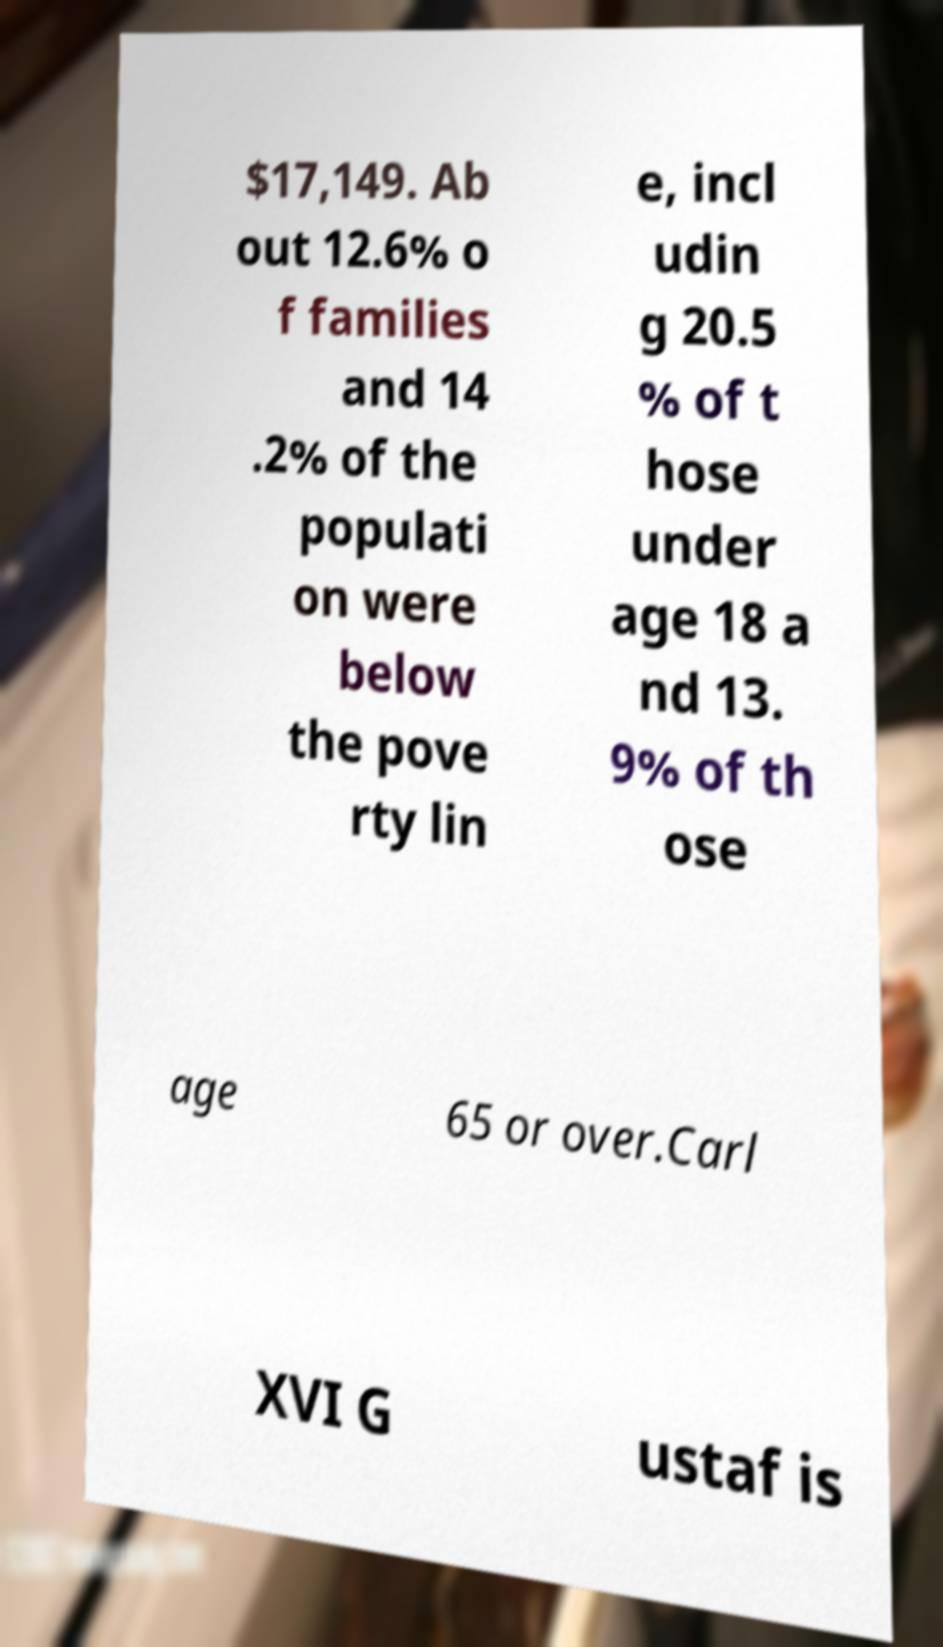There's text embedded in this image that I need extracted. Can you transcribe it verbatim? $17,149. Ab out 12.6% o f families and 14 .2% of the populati on were below the pove rty lin e, incl udin g 20.5 % of t hose under age 18 a nd 13. 9% of th ose age 65 or over.Carl XVI G ustaf is 